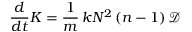<formula> <loc_0><loc_0><loc_500><loc_500>\frac { d } { d t } K = \frac { 1 } { m } \, k N ^ { 2 } \left ( n - 1 \right ) \mathcal { D }</formula> 